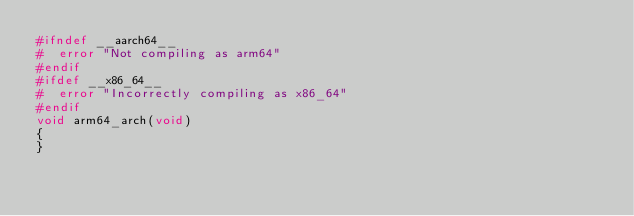<code> <loc_0><loc_0><loc_500><loc_500><_C_>#ifndef __aarch64__
#  error "Not compiling as arm64"
#endif
#ifdef __x86_64__
#  error "Incorrectly compiling as x86_64"
#endif
void arm64_arch(void)
{
}
</code> 